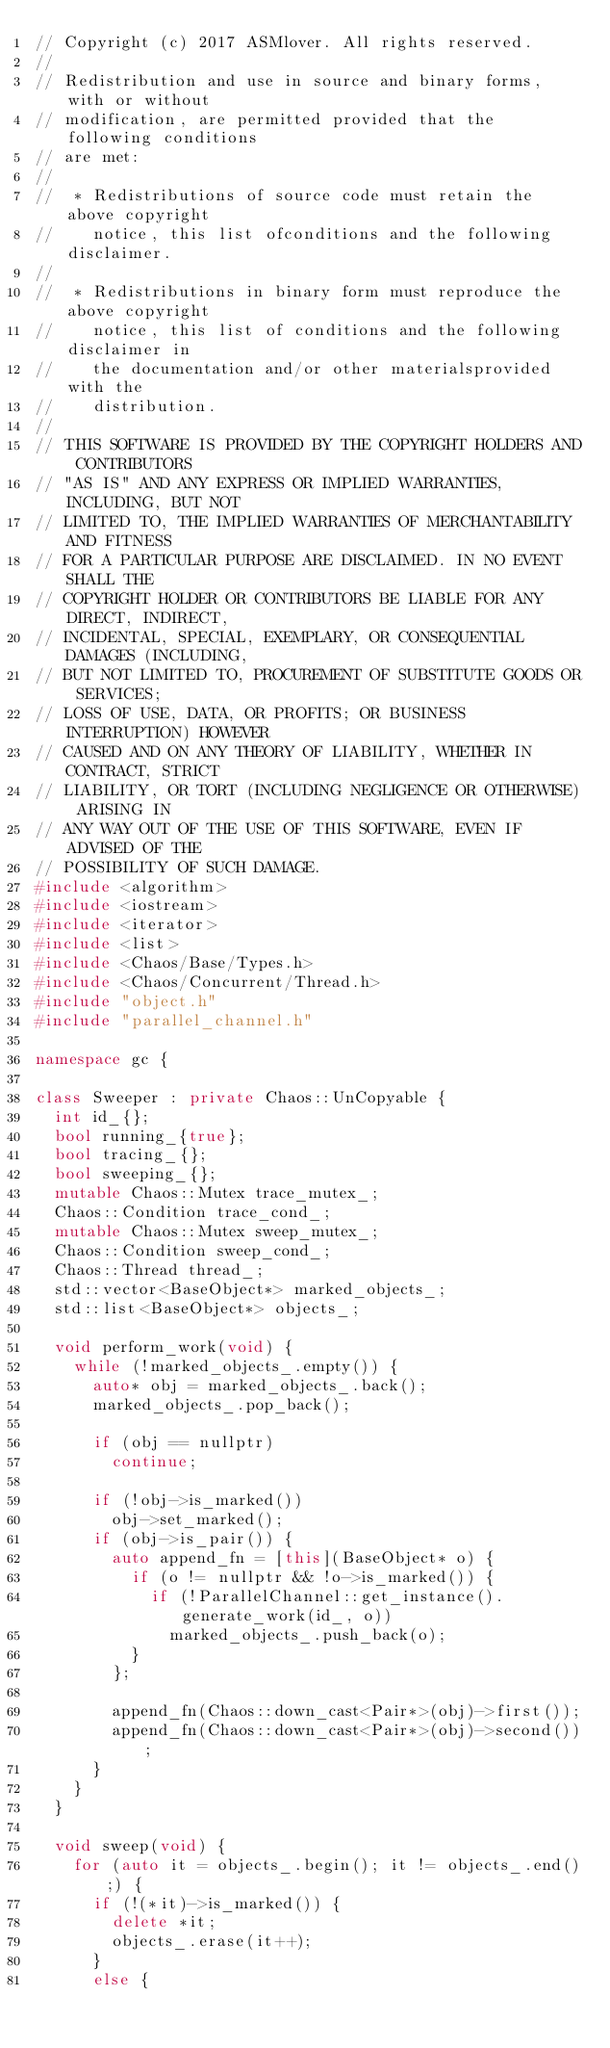Convert code to text. <code><loc_0><loc_0><loc_500><loc_500><_C++_>// Copyright (c) 2017 ASMlover. All rights reserved.
//
// Redistribution and use in source and binary forms, with or without
// modification, are permitted provided that the following conditions
// are met:
//
//  * Redistributions of source code must retain the above copyright
//    notice, this list ofconditions and the following disclaimer.
//
//  * Redistributions in binary form must reproduce the above copyright
//    notice, this list of conditions and the following disclaimer in
//    the documentation and/or other materialsprovided with the
//    distribution.
//
// THIS SOFTWARE IS PROVIDED BY THE COPYRIGHT HOLDERS AND CONTRIBUTORS
// "AS IS" AND ANY EXPRESS OR IMPLIED WARRANTIES, INCLUDING, BUT NOT
// LIMITED TO, THE IMPLIED WARRANTIES OF MERCHANTABILITY AND FITNESS
// FOR A PARTICULAR PURPOSE ARE DISCLAIMED. IN NO EVENT SHALL THE
// COPYRIGHT HOLDER OR CONTRIBUTORS BE LIABLE FOR ANY DIRECT, INDIRECT,
// INCIDENTAL, SPECIAL, EXEMPLARY, OR CONSEQUENTIAL DAMAGES (INCLUDING,
// BUT NOT LIMITED TO, PROCUREMENT OF SUBSTITUTE GOODS OR SERVICES;
// LOSS OF USE, DATA, OR PROFITS; OR BUSINESS INTERRUPTION) HOWEVER
// CAUSED AND ON ANY THEORY OF LIABILITY, WHETHER IN CONTRACT, STRICT
// LIABILITY, OR TORT (INCLUDING NEGLIGENCE OR OTHERWISE) ARISING IN
// ANY WAY OUT OF THE USE OF THIS SOFTWARE, EVEN IF ADVISED OF THE
// POSSIBILITY OF SUCH DAMAGE.
#include <algorithm>
#include <iostream>
#include <iterator>
#include <list>
#include <Chaos/Base/Types.h>
#include <Chaos/Concurrent/Thread.h>
#include "object.h"
#include "parallel_channel.h"

namespace gc {

class Sweeper : private Chaos::UnCopyable {
  int id_{};
  bool running_{true};
  bool tracing_{};
  bool sweeping_{};
  mutable Chaos::Mutex trace_mutex_;
  Chaos::Condition trace_cond_;
  mutable Chaos::Mutex sweep_mutex_;
  Chaos::Condition sweep_cond_;
  Chaos::Thread thread_;
  std::vector<BaseObject*> marked_objects_;
  std::list<BaseObject*> objects_;

  void perform_work(void) {
    while (!marked_objects_.empty()) {
      auto* obj = marked_objects_.back();
      marked_objects_.pop_back();

      if (obj == nullptr)
        continue;

      if (!obj->is_marked())
        obj->set_marked();
      if (obj->is_pair()) {
        auto append_fn = [this](BaseObject* o) {
          if (o != nullptr && !o->is_marked()) {
            if (!ParallelChannel::get_instance().generate_work(id_, o))
              marked_objects_.push_back(o);
          }
        };

        append_fn(Chaos::down_cast<Pair*>(obj)->first());
        append_fn(Chaos::down_cast<Pair*>(obj)->second());
      }
    }
  }

  void sweep(void) {
    for (auto it = objects_.begin(); it != objects_.end();) {
      if (!(*it)->is_marked()) {
        delete *it;
        objects_.erase(it++);
      }
      else {</code> 